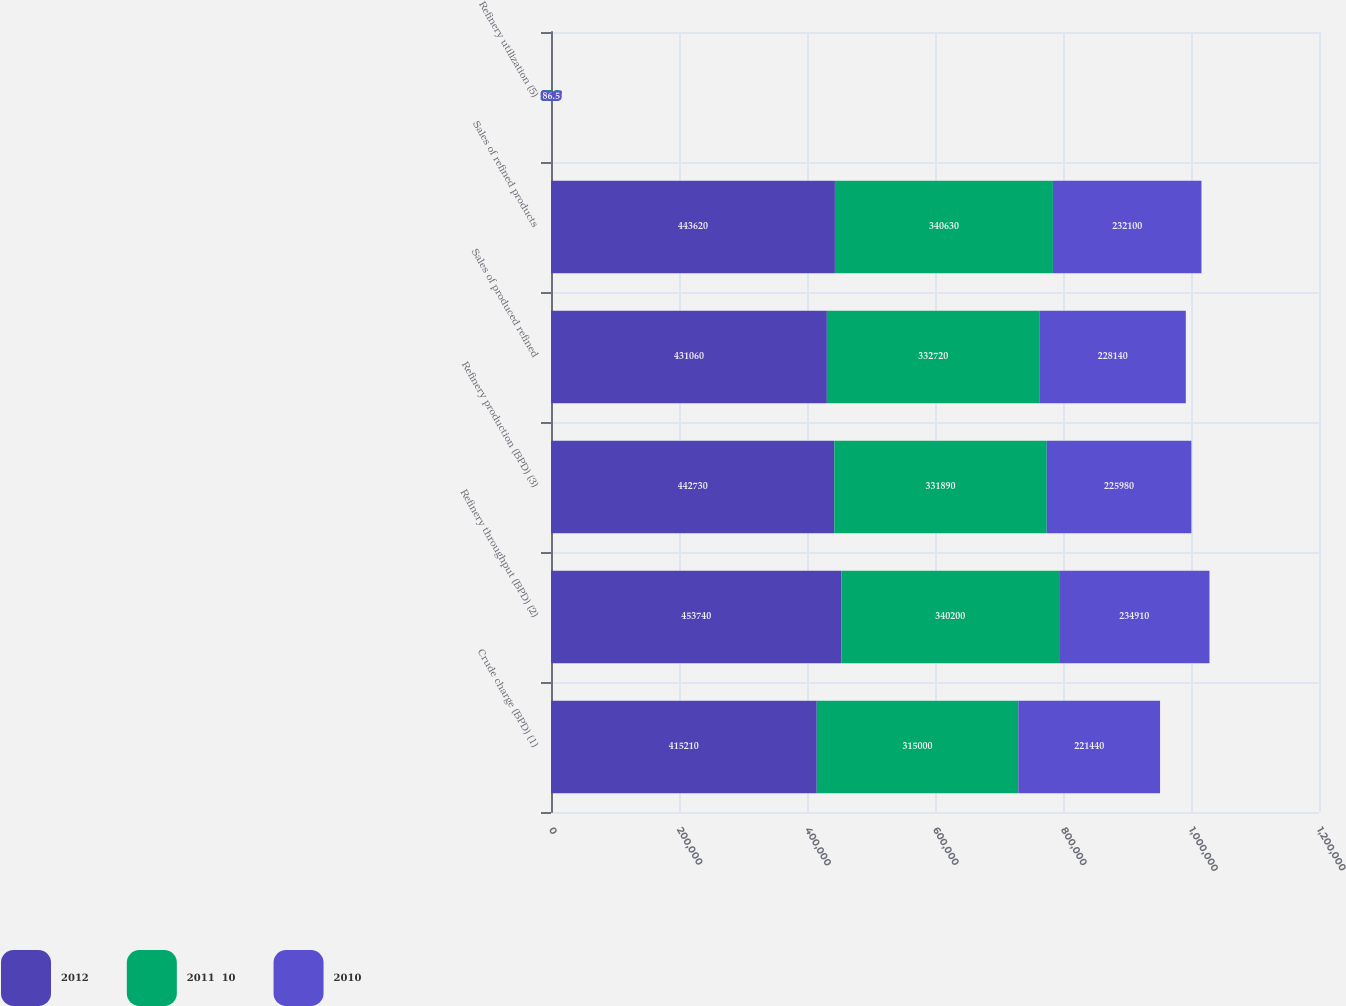Convert chart. <chart><loc_0><loc_0><loc_500><loc_500><stacked_bar_chart><ecel><fcel>Crude charge (BPD) (1)<fcel>Refinery throughput (BPD) (2)<fcel>Refinery production (BPD) (3)<fcel>Sales of produced refined<fcel>Sales of refined products<fcel>Refinery utilization (5)<nl><fcel>2012<fcel>415210<fcel>453740<fcel>442730<fcel>431060<fcel>443620<fcel>93.7<nl><fcel>2011  10<fcel>315000<fcel>340200<fcel>331890<fcel>332720<fcel>340630<fcel>89.9<nl><fcel>2010<fcel>221440<fcel>234910<fcel>225980<fcel>228140<fcel>232100<fcel>86.5<nl></chart> 